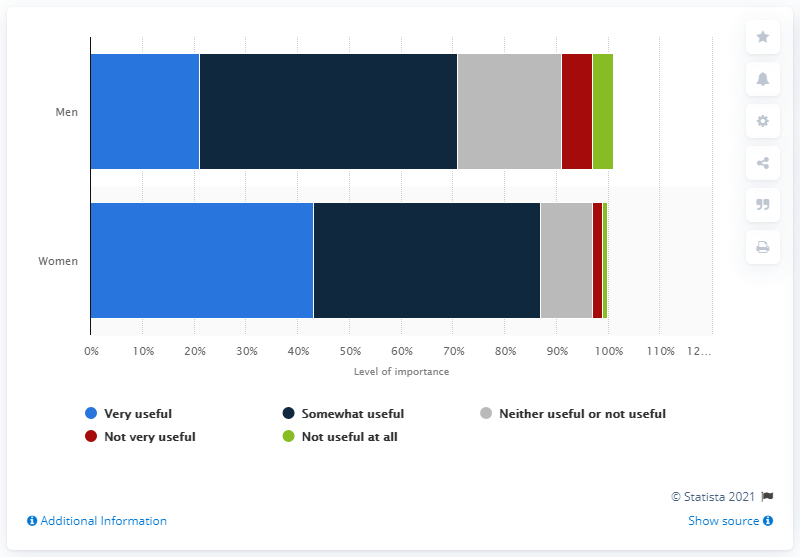Draw attention to some important aspects in this diagram. In the survey of male respondents, it was found that 21% believed that lower-calorie menu options were helpful. 